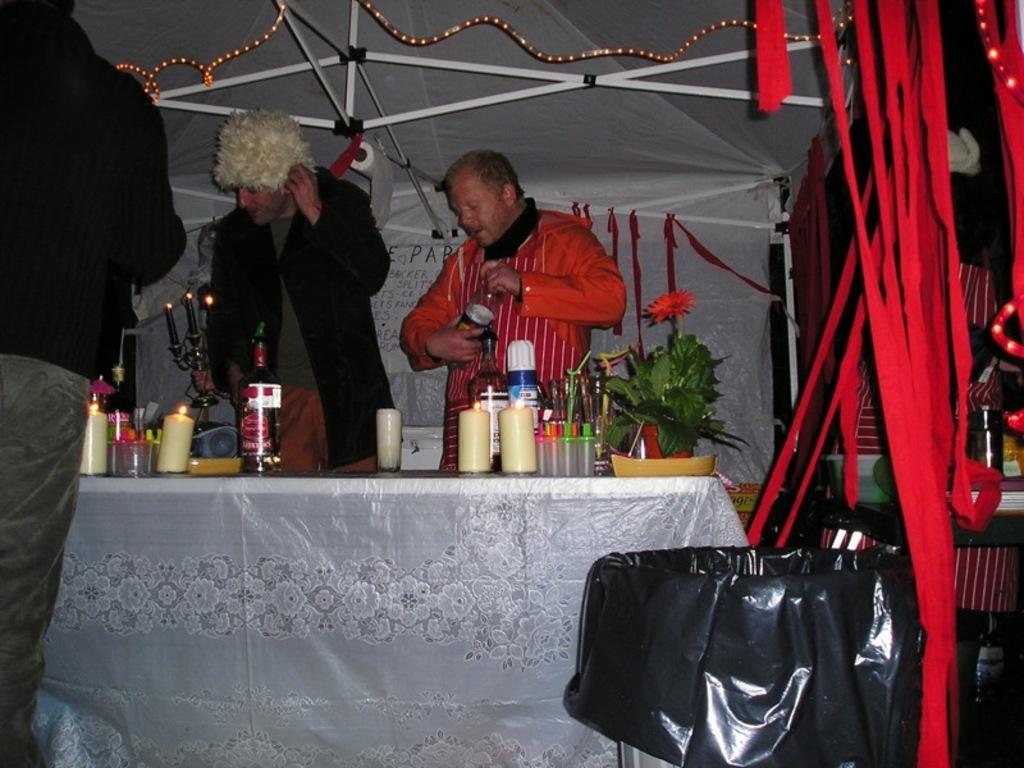Who or what can be seen in the image? There are people in the image. What items are present that might be used for drinking? There are bottles in the image. What objects can be seen that provide light? There are candles in the image. What type of plant is visible in the image? There is a houseplant in the image. What type of floral arrangement is present in the image? There are flowers in the image. What additional objects can be seen that serve a decorative purpose? There are decorative objects in the image. What other items can be seen in the image besides those mentioned? There are other objects in the image. What type of crate can be seen in the image? There is no crate present in the image. What sound do the people in the image make? The image does not provide any information about the sounds made by the people, so we cannot determine if they are laughing or making any other specific sound. 